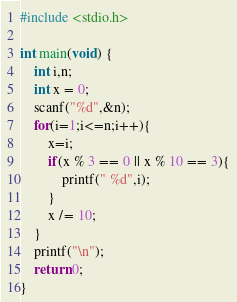Convert code to text. <code><loc_0><loc_0><loc_500><loc_500><_C_>#include <stdio.h>

int main(void) {
	int i,n;
	int x = 0;
	scanf("%d",&n);
	for(i=1;i<=n;i++){
		x=i;
		if(x % 3 == 0 || x % 10 == 3){
			printf(" %d",i);
		}
		x /= 10;
	}
	printf("\n");
	return 0;
}</code> 